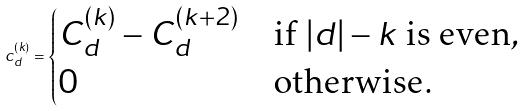<formula> <loc_0><loc_0><loc_500><loc_500>c _ { d } ^ { ( k ) } = \begin{cases} C _ { d } ^ { ( k ) } - C _ { d } ^ { ( k + 2 ) } & \text {if $|d|-k$ is even} , \\ 0 & \text {otherwise} . \end{cases}</formula> 